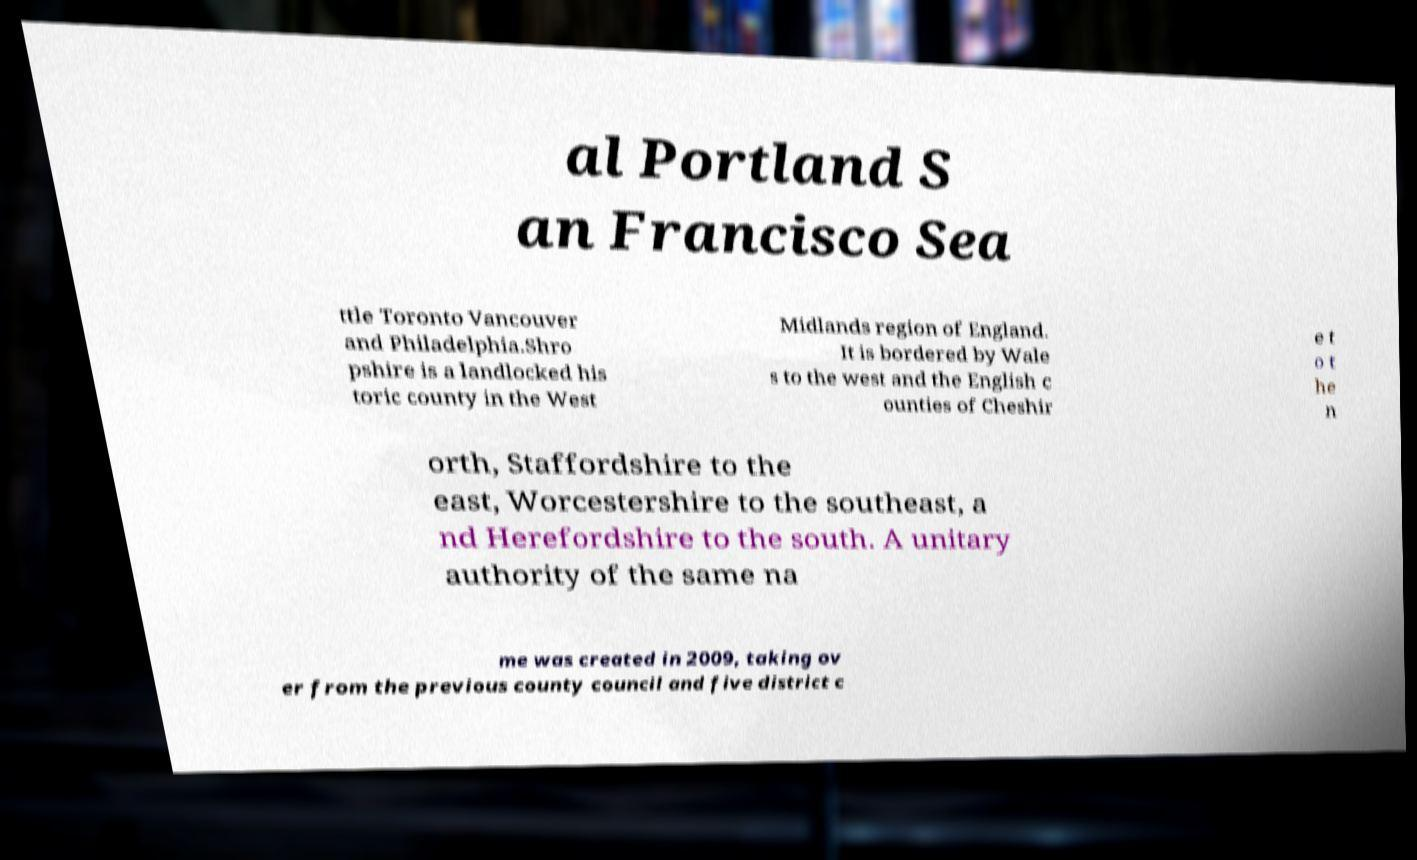Please identify and transcribe the text found in this image. al Portland S an Francisco Sea ttle Toronto Vancouver and Philadelphia.Shro pshire is a landlocked his toric county in the West Midlands region of England. It is bordered by Wale s to the west and the English c ounties of Cheshir e t o t he n orth, Staffordshire to the east, Worcestershire to the southeast, a nd Herefordshire to the south. A unitary authority of the same na me was created in 2009, taking ov er from the previous county council and five district c 